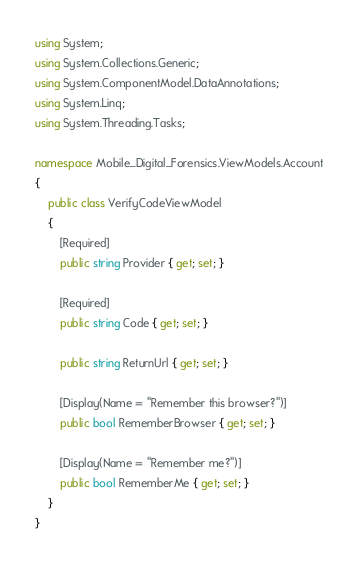Convert code to text. <code><loc_0><loc_0><loc_500><loc_500><_C#_>using System;
using System.Collections.Generic;
using System.ComponentModel.DataAnnotations;
using System.Linq;
using System.Threading.Tasks;

namespace Mobile_Digital_Forensics.ViewModels.Account
{
    public class VerifyCodeViewModel
    {
        [Required]
        public string Provider { get; set; }

        [Required]
        public string Code { get; set; }

        public string ReturnUrl { get; set; }

        [Display(Name = "Remember this browser?")]
        public bool RememberBrowser { get; set; }

        [Display(Name = "Remember me?")]
        public bool RememberMe { get; set; }
    }
}
</code> 